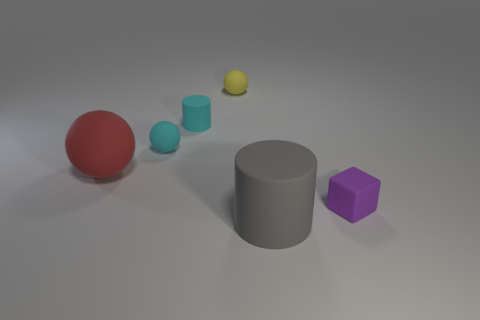What is the material of the gray thing?
Provide a succinct answer. Rubber. What shape is the tiny thing in front of the large rubber thing that is on the left side of the cylinder that is behind the big cylinder?
Keep it short and to the point. Cube. What number of other things are the same material as the tiny yellow sphere?
Ensure brevity in your answer.  5. Is the material of the thing that is in front of the purple matte block the same as the small thing that is in front of the red object?
Keep it short and to the point. Yes. What number of large objects are both on the left side of the big gray rubber thing and in front of the red sphere?
Ensure brevity in your answer.  0. Are there any other large things of the same shape as the big gray matte object?
Provide a short and direct response. No. There is a yellow object that is the same size as the purple block; what shape is it?
Your response must be concise. Sphere. Are there an equal number of big red balls behind the tiny cyan cylinder and tiny rubber spheres that are to the right of the big gray cylinder?
Provide a short and direct response. Yes. There is a cylinder that is behind the large rubber object in front of the big red matte thing; what is its size?
Keep it short and to the point. Small. Is there a blue sphere of the same size as the red thing?
Ensure brevity in your answer.  No. 